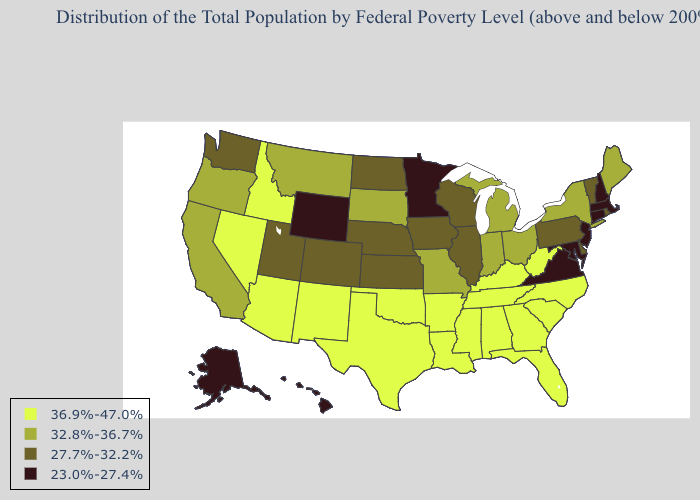Name the states that have a value in the range 36.9%-47.0%?
Write a very short answer. Alabama, Arizona, Arkansas, Florida, Georgia, Idaho, Kentucky, Louisiana, Mississippi, Nevada, New Mexico, North Carolina, Oklahoma, South Carolina, Tennessee, Texas, West Virginia. Name the states that have a value in the range 27.7%-32.2%?
Concise answer only. Colorado, Delaware, Illinois, Iowa, Kansas, Nebraska, North Dakota, Pennsylvania, Rhode Island, Utah, Vermont, Washington, Wisconsin. What is the value of Minnesota?
Keep it brief. 23.0%-27.4%. Does Iowa have the lowest value in the USA?
Concise answer only. No. Does Texas have the highest value in the South?
Quick response, please. Yes. What is the value of Massachusetts?
Short answer required. 23.0%-27.4%. What is the lowest value in the Northeast?
Concise answer only. 23.0%-27.4%. Does the map have missing data?
Be succinct. No. Among the states that border Pennsylvania , does Ohio have the highest value?
Keep it brief. No. Does Rhode Island have a higher value than Wisconsin?
Concise answer only. No. How many symbols are there in the legend?
Give a very brief answer. 4. What is the highest value in the USA?
Answer briefly. 36.9%-47.0%. What is the highest value in states that border Delaware?
Answer briefly. 27.7%-32.2%. Among the states that border Michigan , does Indiana have the lowest value?
Keep it brief. No. How many symbols are there in the legend?
Concise answer only. 4. 